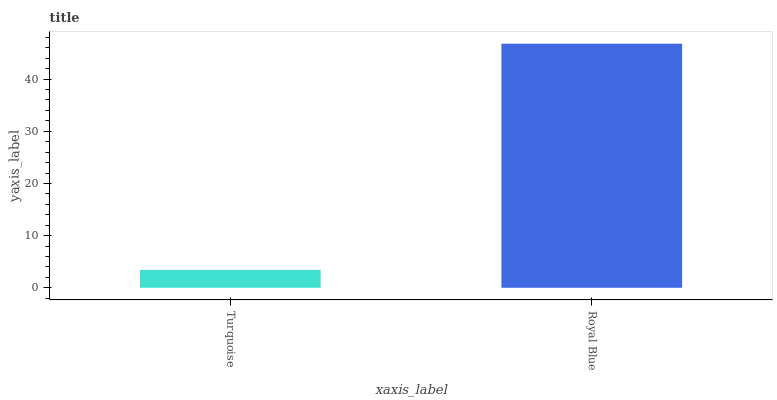Is Turquoise the minimum?
Answer yes or no. Yes. Is Royal Blue the maximum?
Answer yes or no. Yes. Is Royal Blue the minimum?
Answer yes or no. No. Is Royal Blue greater than Turquoise?
Answer yes or no. Yes. Is Turquoise less than Royal Blue?
Answer yes or no. Yes. Is Turquoise greater than Royal Blue?
Answer yes or no. No. Is Royal Blue less than Turquoise?
Answer yes or no. No. Is Royal Blue the high median?
Answer yes or no. Yes. Is Turquoise the low median?
Answer yes or no. Yes. Is Turquoise the high median?
Answer yes or no. No. Is Royal Blue the low median?
Answer yes or no. No. 